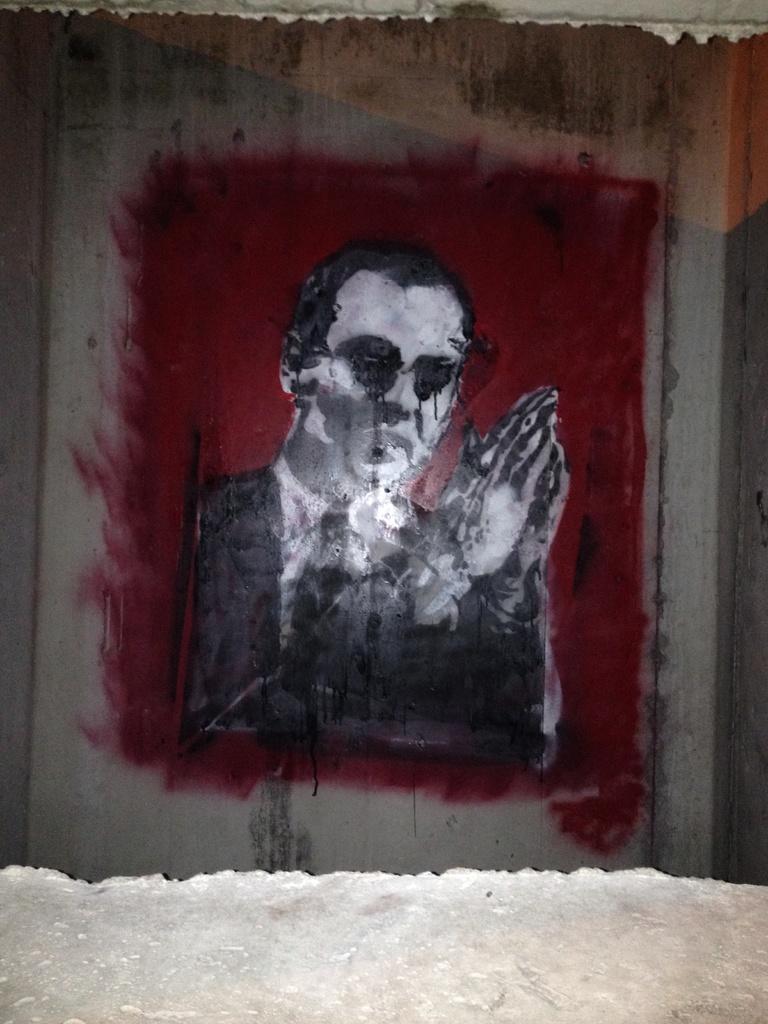Could you give a brief overview of what you see in this image? This picture shows painting of a man on the wall. 